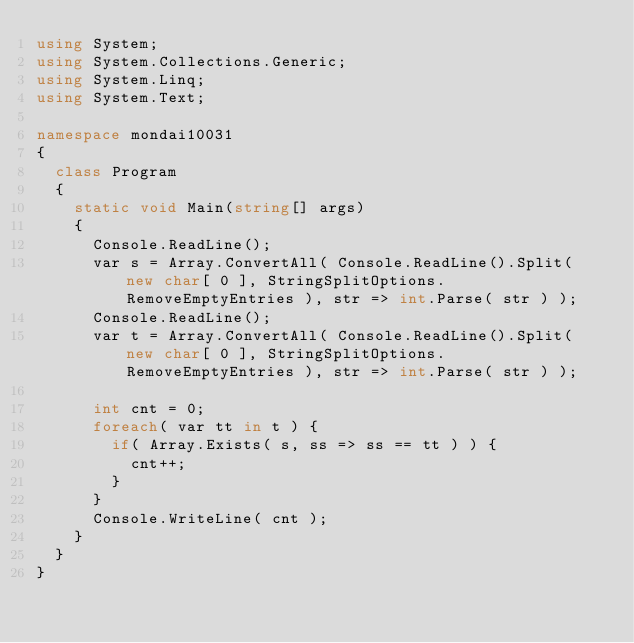<code> <loc_0><loc_0><loc_500><loc_500><_C#_>using System;
using System.Collections.Generic;
using System.Linq;
using System.Text;

namespace mondai10031
{
	class Program
	{
		static void Main(string[] args)
		{
			Console.ReadLine();
			var	s	= Array.ConvertAll( Console.ReadLine().Split( new char[ 0 ], StringSplitOptions.RemoveEmptyEntries ), str => int.Parse( str ) );
			Console.ReadLine();
			var	t	= Array.ConvertAll( Console.ReadLine().Split( new char[ 0 ], StringSplitOptions.RemoveEmptyEntries ), str => int.Parse( str ) );

			int	cnt	= 0;
			foreach( var tt in t ) {
				if( Array.Exists( s, ss => ss == tt ) ) {
					cnt++;
				}
			}
			Console.WriteLine( cnt );
		}
	}
}</code> 